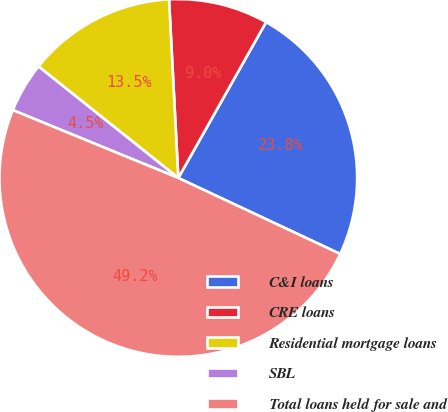Convert chart. <chart><loc_0><loc_0><loc_500><loc_500><pie_chart><fcel>C&I loans<fcel>CRE loans<fcel>Residential mortgage loans<fcel>SBL<fcel>Total loans held for sale and<nl><fcel>23.82%<fcel>8.99%<fcel>13.46%<fcel>4.52%<fcel>49.21%<nl></chart> 